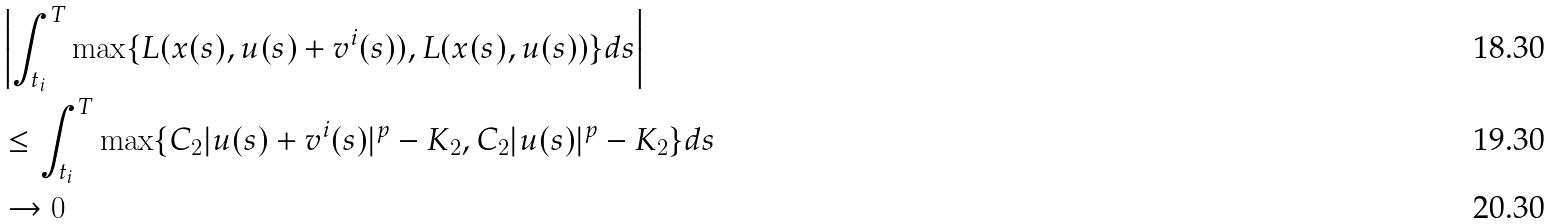<formula> <loc_0><loc_0><loc_500><loc_500>& \left | \int _ { t _ { i } } ^ { T } \max \{ L ( x ( s ) , u ( s ) + v ^ { i } ( s ) ) , L ( x ( s ) , u ( s ) ) \} d s \right | \\ & \leq \int _ { t _ { i } } ^ { T } \max \{ C _ { 2 } | u ( s ) + v ^ { i } ( s ) | ^ { p } - K _ { 2 } , C _ { 2 } | u ( s ) | ^ { p } - K _ { 2 } \} d s \\ & \to 0</formula> 